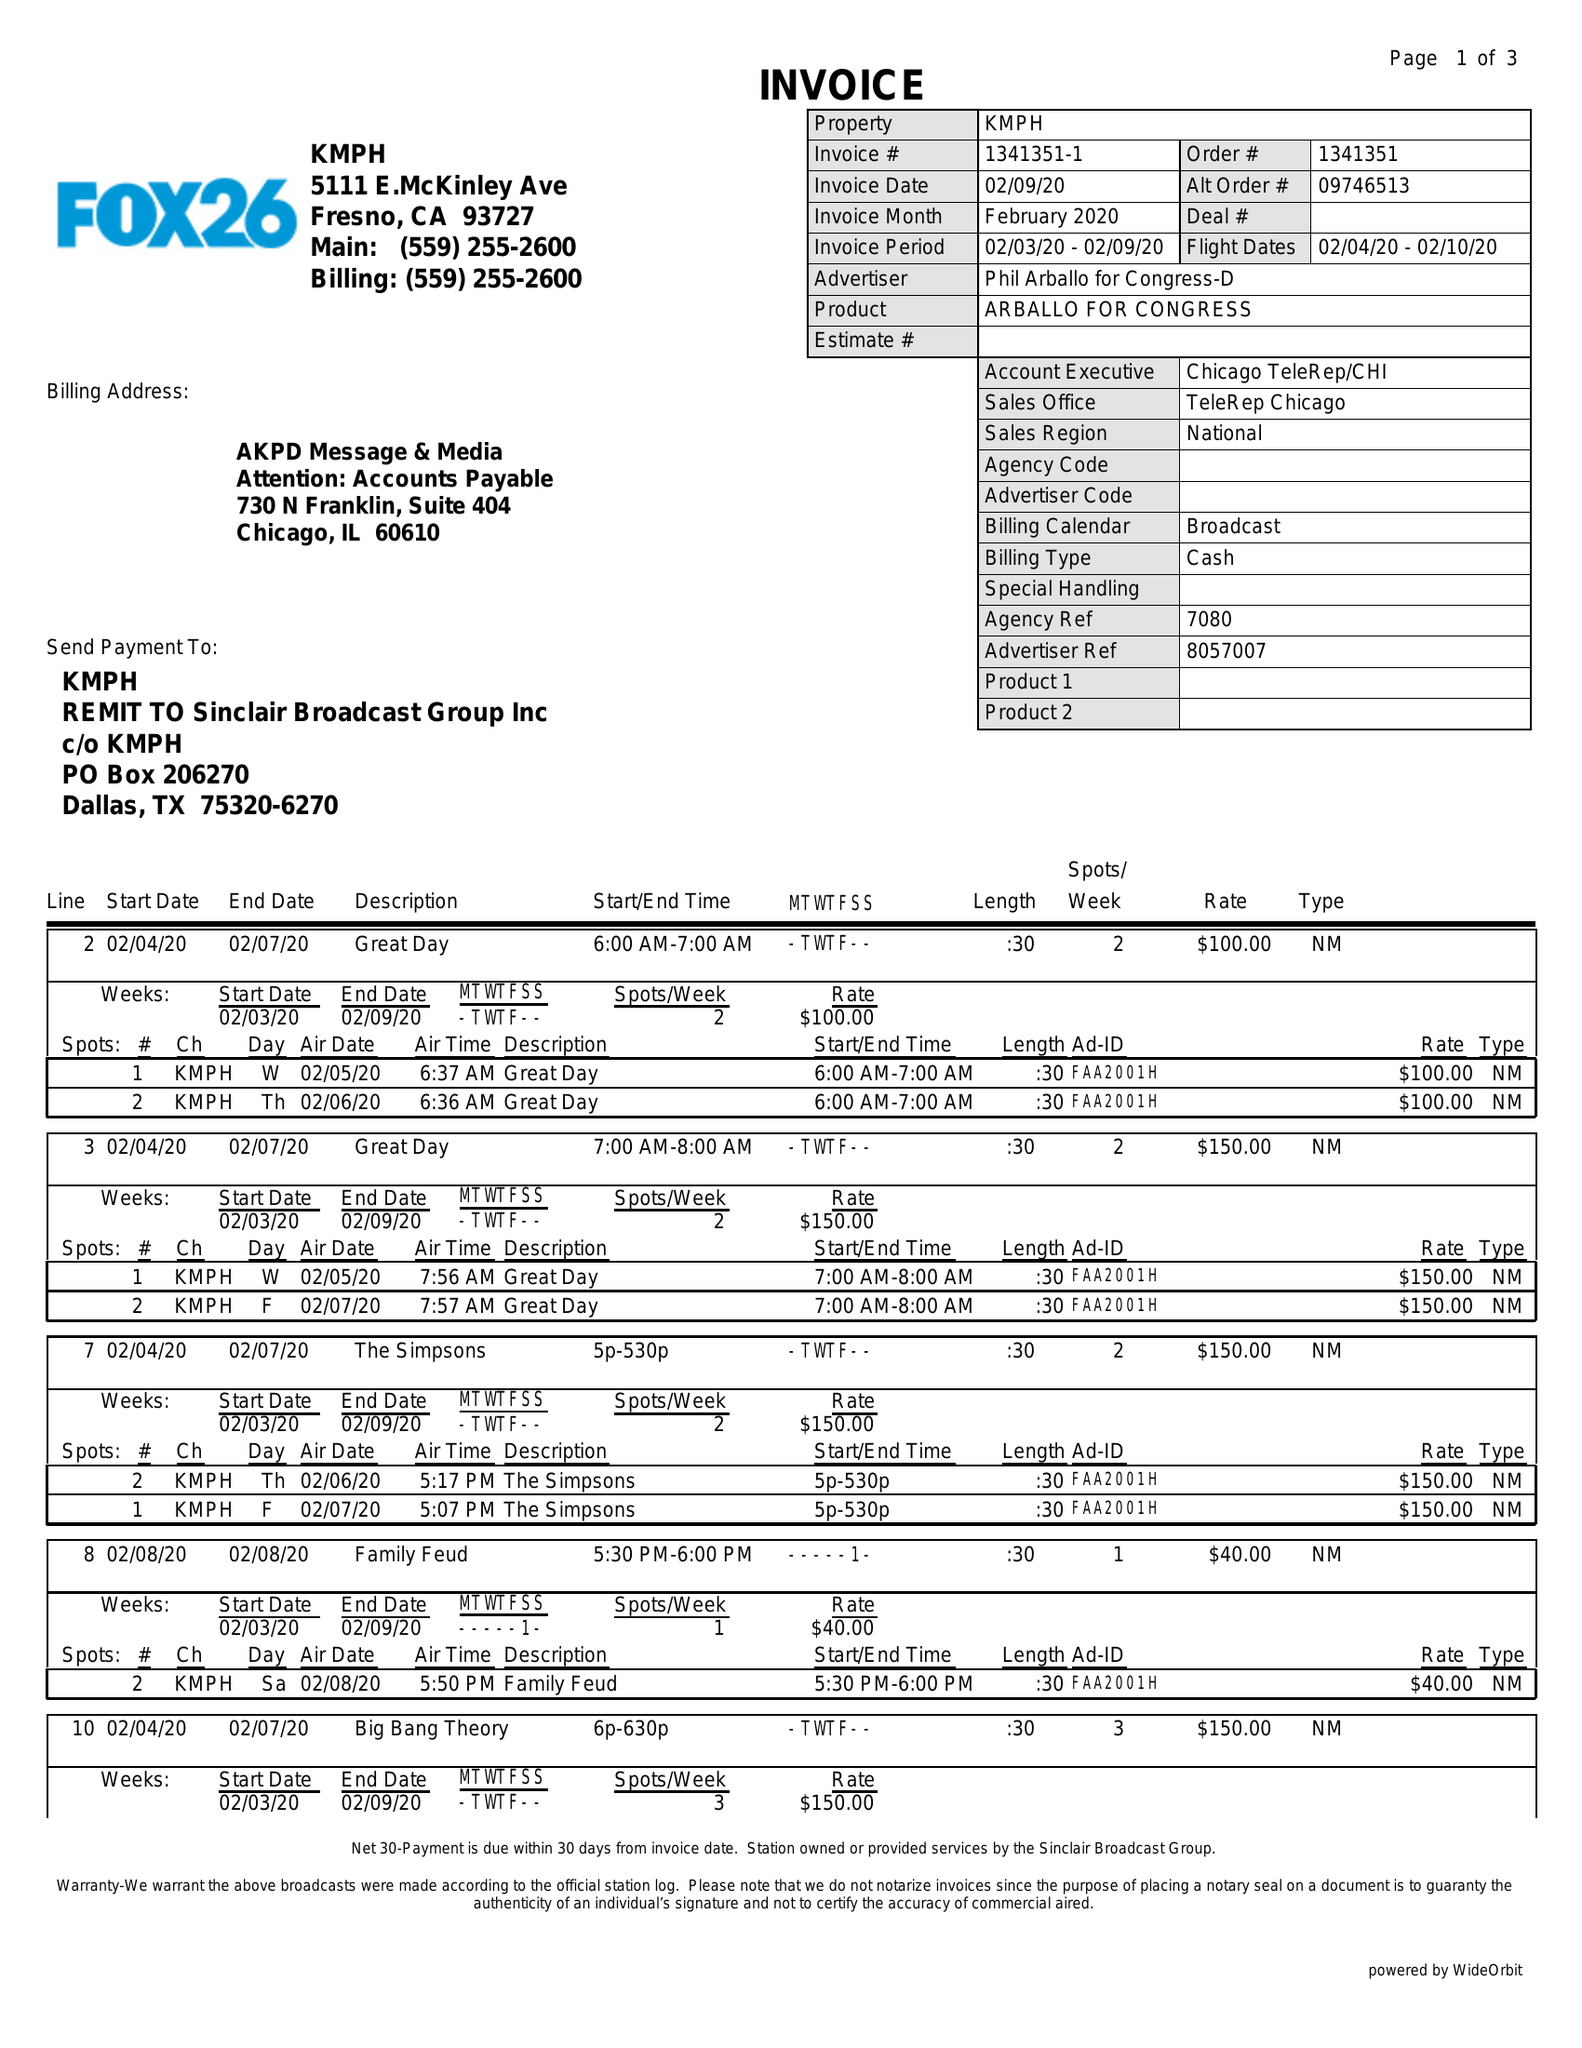What is the value for the flight_to?
Answer the question using a single word or phrase. 02/10/20 